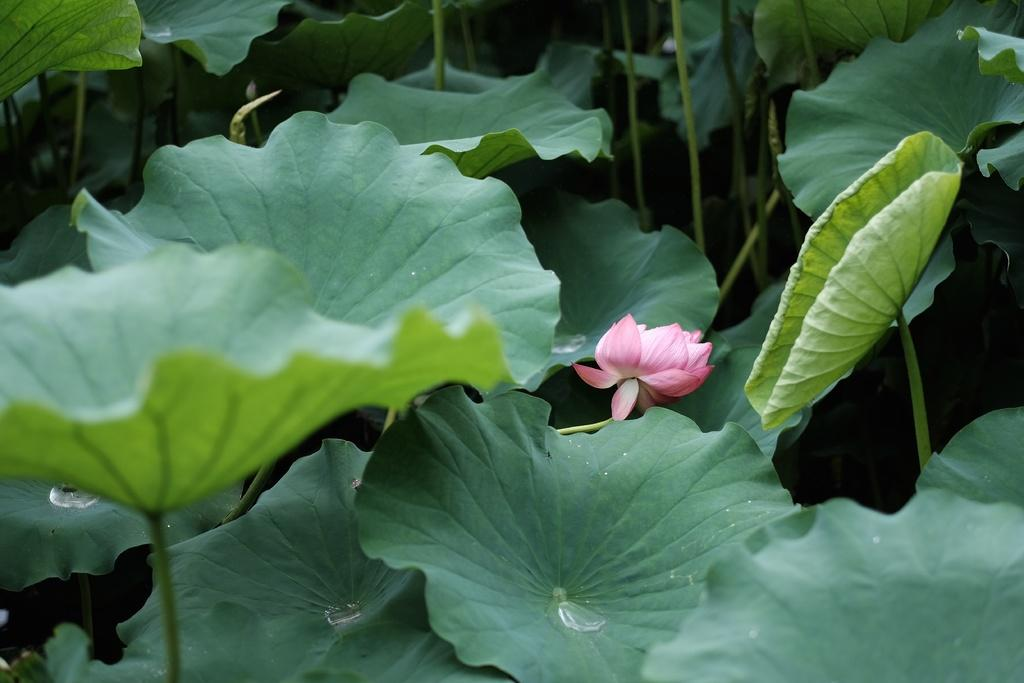What type of plant is depicted in the image? The image contains a flower, leaves, and stems, which are all parts of a plant. Can you describe the different components of the plant in the image? There is a flower, leaves, and stems visible in the image. What might be the purpose of the stems in the image? The stems in the image provide support and help transport nutrients and water to the flower and leaves. What type of wound can be seen on the stage in the image? There is no stage or wound present in the image; it features a plant with a flower, leaves, and stems. How does the acoustics of the image affect the sound quality of the plant? The image does not depict any sound-related elements, so it is not possible to determine the acoustics or how they might affect the plant. 